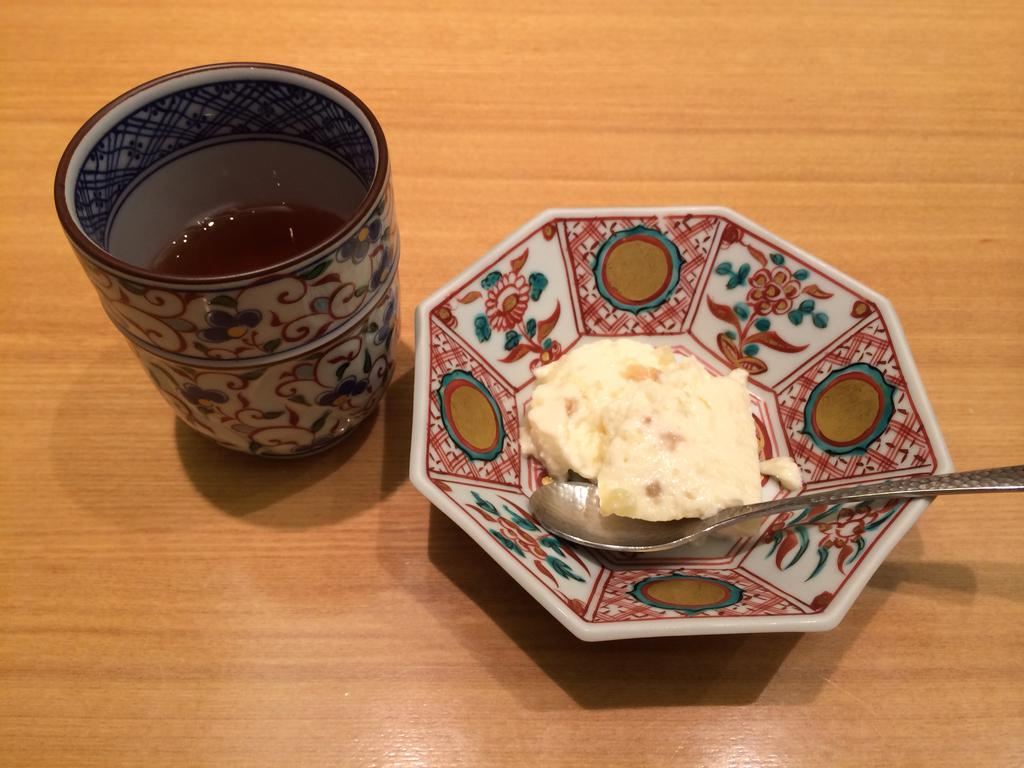What is on the plate that is visible in the image? There is a plate containing ice cream in the image. What utensil is present on the plate? There is a spoon on the plate. What is in the glass that is visible in the image? There is a glass containing liquid in the image. What type of furniture is present in the image? The wooden table is present in the image. How does the ice cream attempt to start a conversation with the glass in the image? The ice cream does not attempt to start a conversation with the glass in the image, as they are inanimate objects and cannot communicate. 